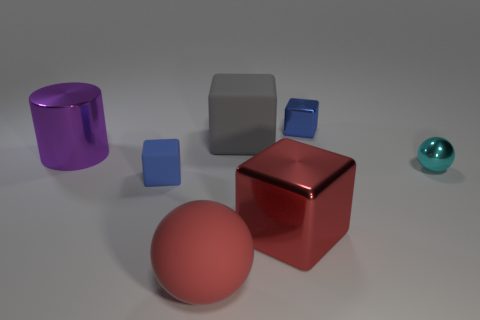There is a red matte object; what number of tiny metal cubes are on the left side of it? In the image, to the immediate left of the red matte object, there are no tiny metal cubes present. 